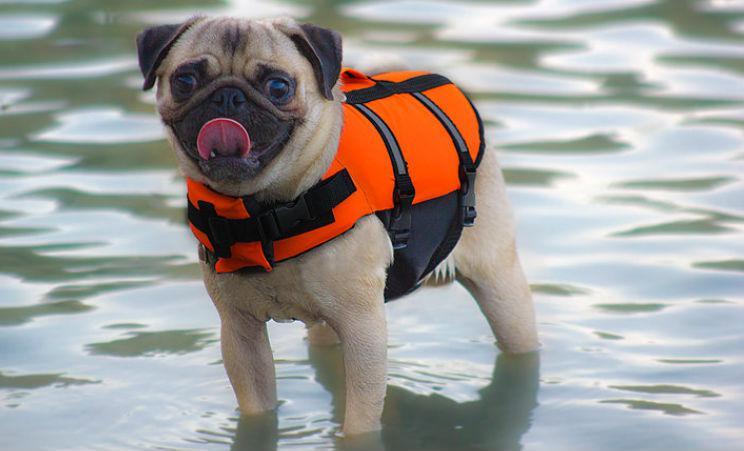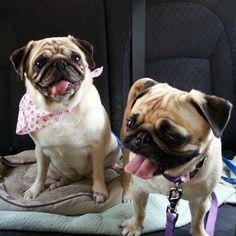The first image is the image on the left, the second image is the image on the right. Given the left and right images, does the statement "There are three dogs." hold true? Answer yes or no. Yes. 